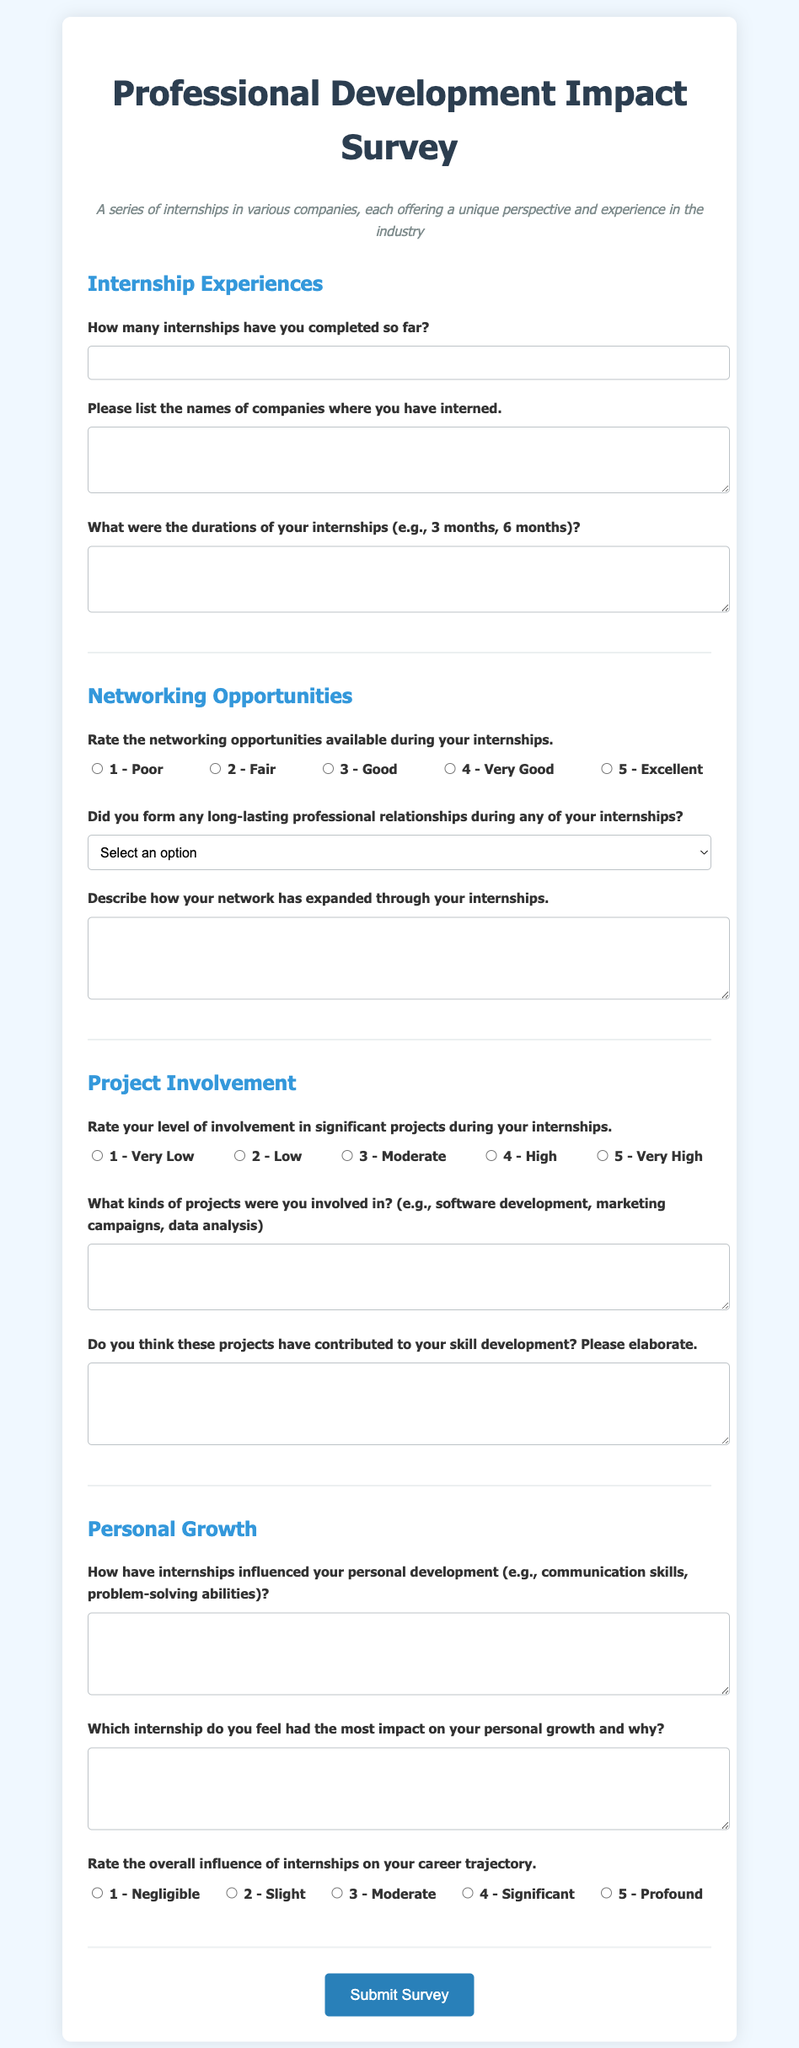How many sections are there in the survey? The survey is divided into several distinct sections, each focused on a different topic related to internships.
Answer: 4 What is the maximum number of internships a participant can indicate they have completed? The form uses a numeric input field for the number of internships, and the minimum is 0.
Answer: No maximum limit specified What kind of rating scale is used for networking opportunities? The survey provides a 5-point rating scale for evaluating networking opportunities during internships.
Answer: 1 to 5 Which question asks about the impact on personal growth? The question specifically inquires about how internships have influenced personal development.
Answer: How have internships influenced your personal development? Is there a question regarding long-lasting professional relationships? This inquiry is included to determine if internships helped in forming valuable professional connections.
Answer: Yes 